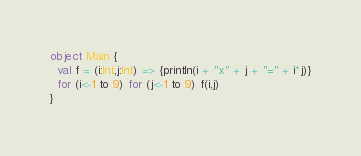Convert code to text. <code><loc_0><loc_0><loc_500><loc_500><_Scala_>object Main {
  val f = (i:Int,j:Int) => {println(i + "x" + j + "=" + i*j)}
  for (i<-1 to 9) for (j<-1 to 9) f(i,j)
}
</code> 